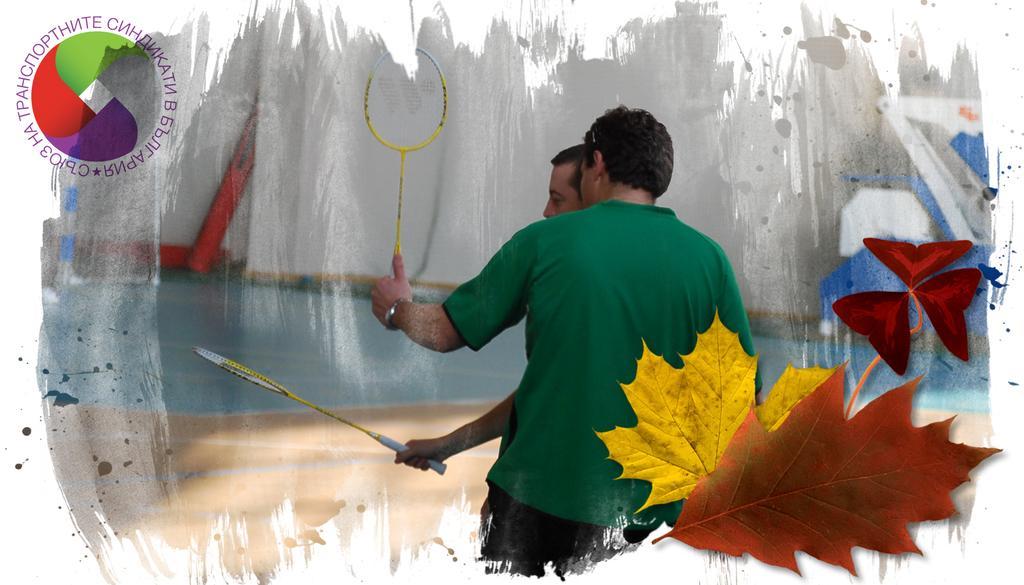In one or two sentences, can you explain what this image depicts? In this edited image, we can see persons holding badminton rackets with their hands. There is a logo in the top left of the image. There are leaves in the bottom right of the image. 